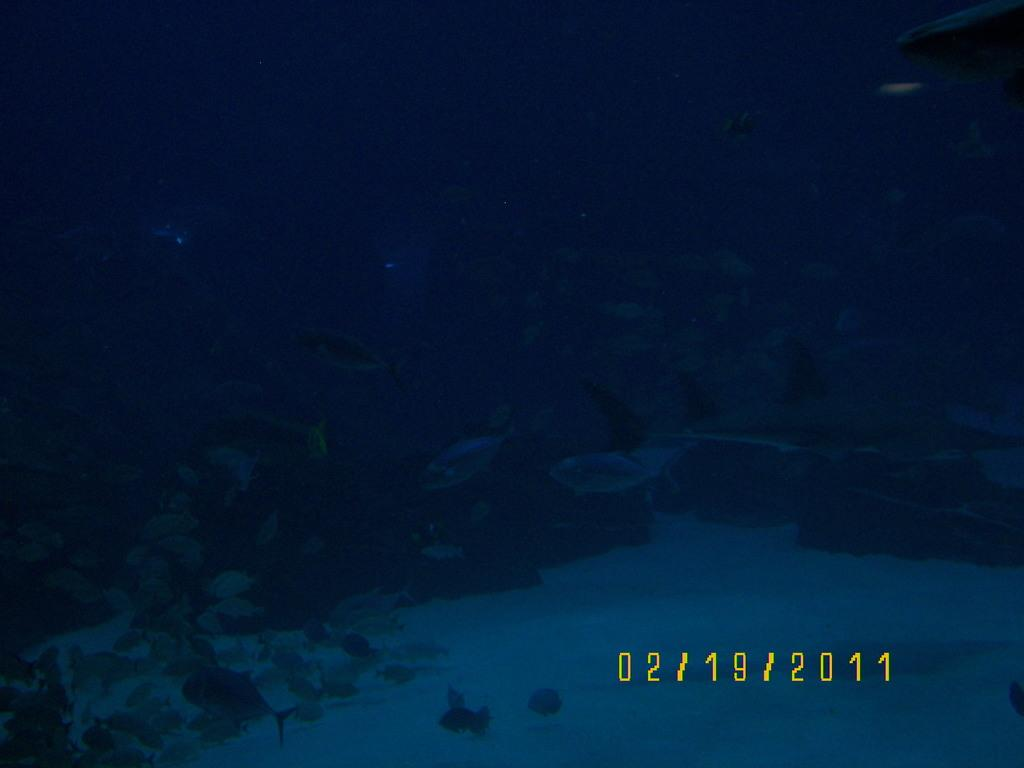What type of living organisms can be seen in the image? Plants and fish are visible in the image. What is the primary element in which the fish are situated? The fish are situated in water in the image. What is written at the bottom of the image? There is text at the bottom of the image. What type of digestion can be observed in the image? There is no digestion present in the image, as it features plants and fish in water with text at the bottom. 